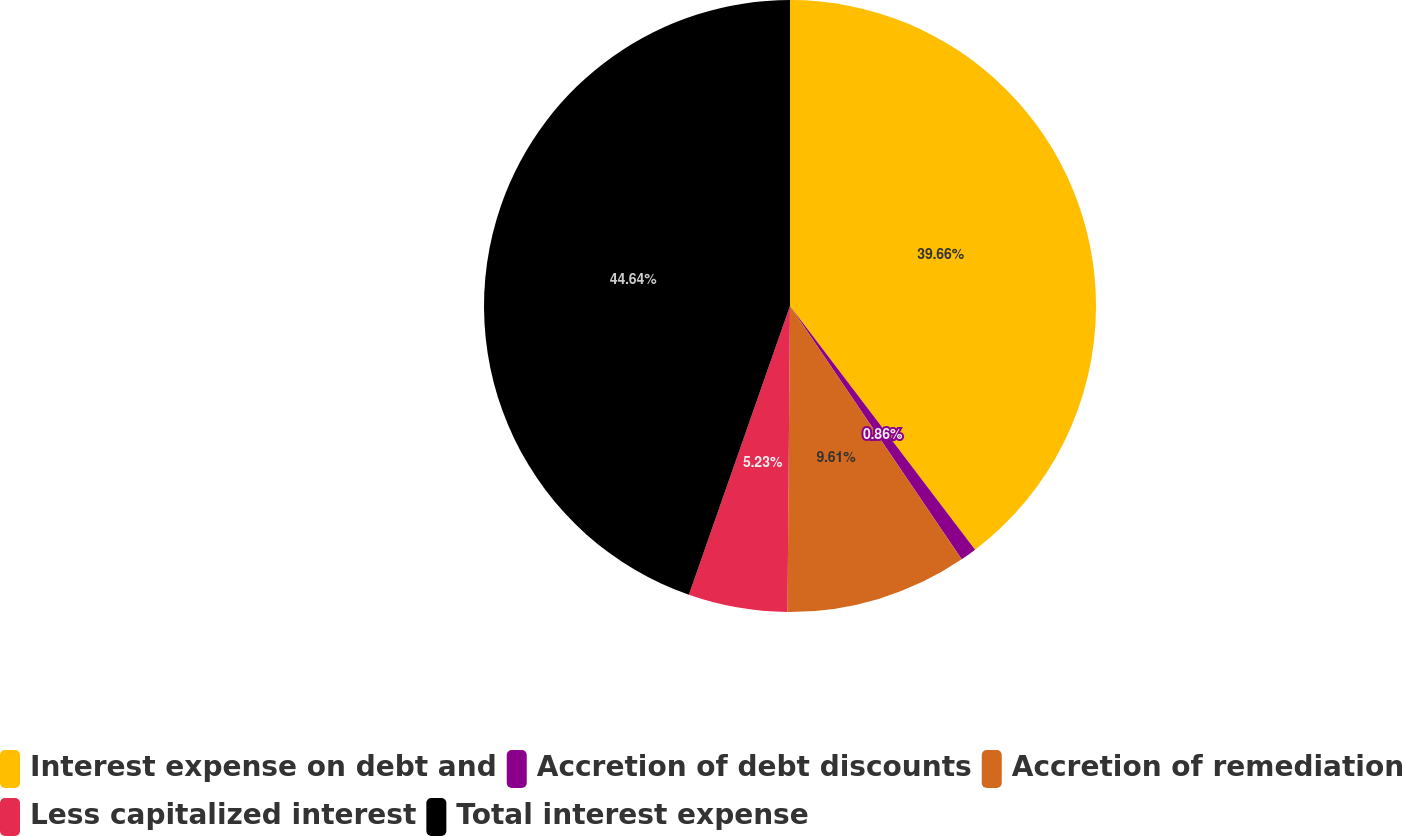<chart> <loc_0><loc_0><loc_500><loc_500><pie_chart><fcel>Interest expense on debt and<fcel>Accretion of debt discounts<fcel>Accretion of remediation<fcel>Less capitalized interest<fcel>Total interest expense<nl><fcel>39.66%<fcel>0.86%<fcel>9.61%<fcel>5.23%<fcel>44.64%<nl></chart> 